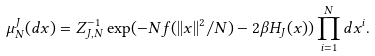<formula> <loc_0><loc_0><loc_500><loc_500>\mu _ { N } ^ { J } ( d x ) = Z _ { J , N } ^ { - 1 } \exp ( - N f ( | | x | | ^ { 2 } / N ) - 2 \beta H _ { J } ( x ) ) \prod _ { i = 1 } ^ { N } d x ^ { i } .</formula> 